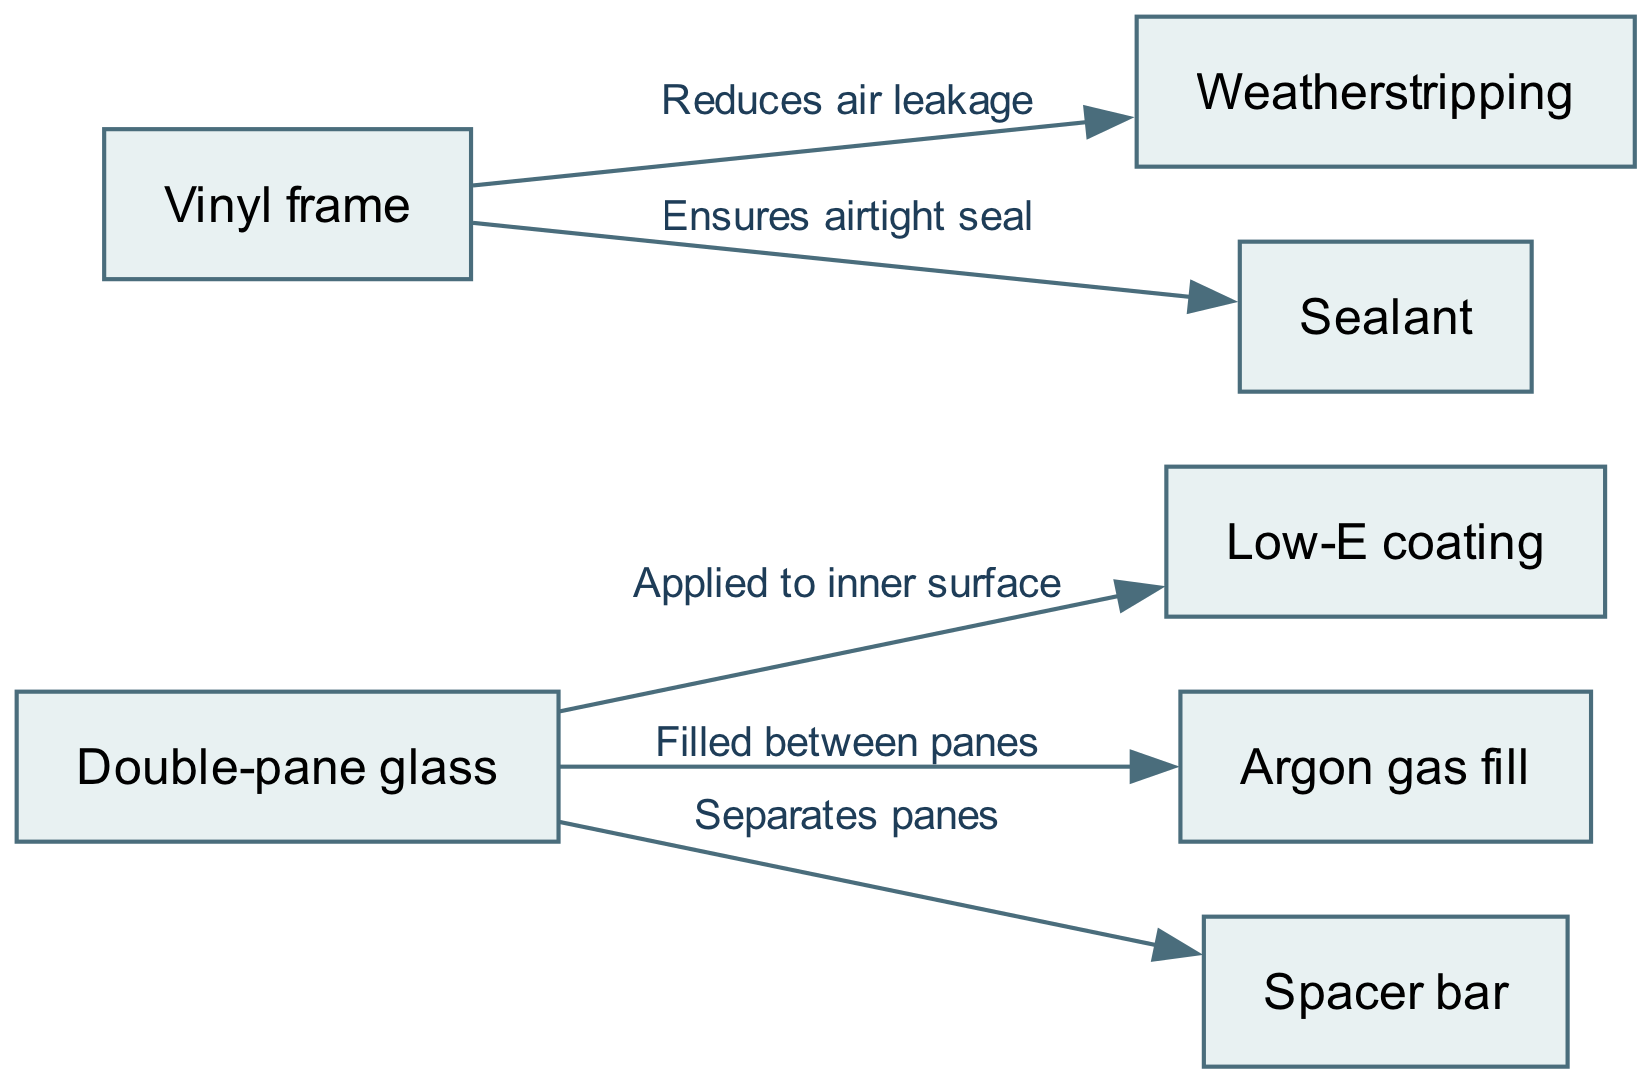What are the components used in the window installation? The diagram lists multiple nodes representing components of the window installation, such as double-pane glass, low-E coating, argon gas fill, vinyl frame, weatherstripping, spacer bar, and sealant.
Answer: Double-pane glass, low-E coating, argon gas fill, vinyl frame, weatherstripping, spacer bar, sealant How many edges are present in the diagram? The connections (edges) between the nodes indicate relationships or functions. Counting these edges reveals that there are a total of five edges in the diagram.
Answer: 5 What is the purpose of the low-E coating? The diagram shows that the low-E coating is applied to the inner surface of the double-pane glass, indicating its use in improving energy efficiency by reflecting heat.
Answer: Reflecting heat What does the vinyl frame do in relation to air leakage? According to the diagram, the vinyl frame connects to weatherstripping, labeling it as reducing air leakage, which means it serves to maintain the integrity and efficiency of the window installation.
Answer: Reduces air leakage What is the function of argon gas in the window? The edge connecting double-pane glass to argon gas fill indicates that argon gas is filled between the panes, which is intended to enhance insulation properties, thus improving energy efficiency.
Answer: Insulation 